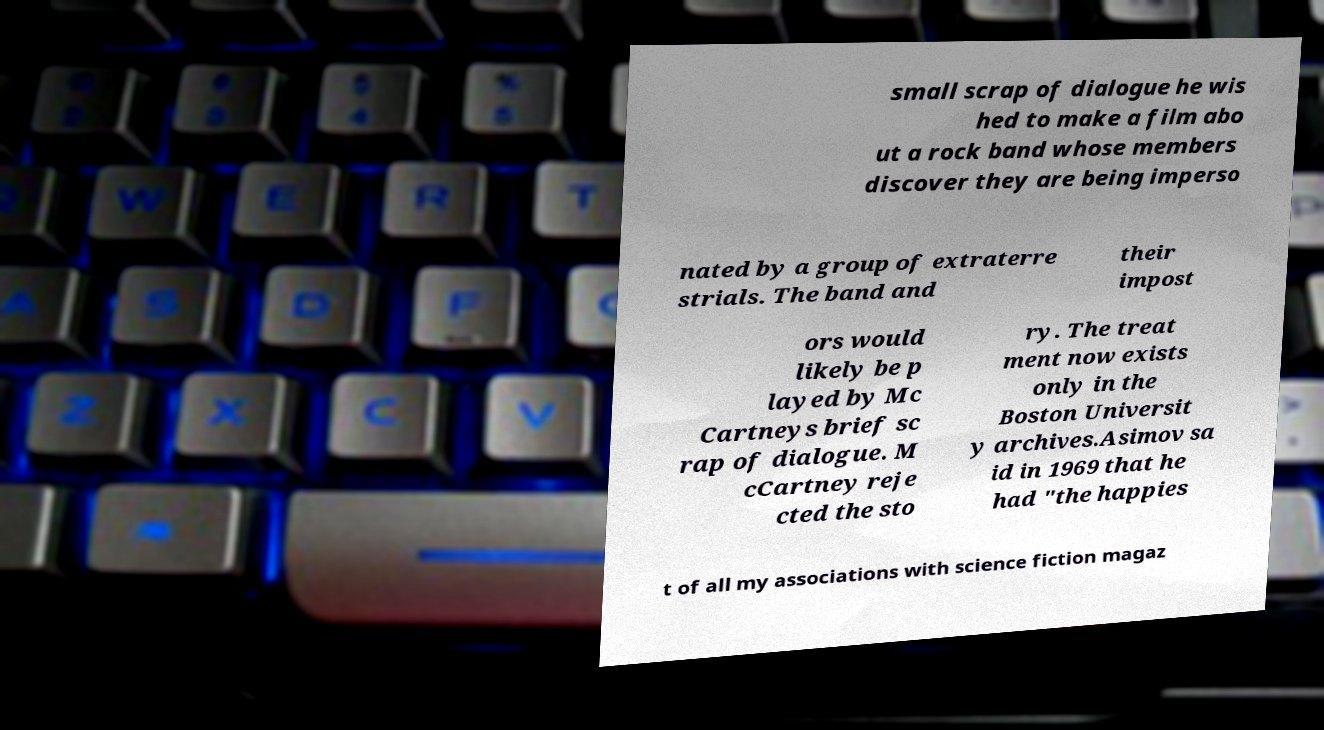Please read and relay the text visible in this image. What does it say? small scrap of dialogue he wis hed to make a film abo ut a rock band whose members discover they are being imperso nated by a group of extraterre strials. The band and their impost ors would likely be p layed by Mc Cartneys brief sc rap of dialogue. M cCartney reje cted the sto ry. The treat ment now exists only in the Boston Universit y archives.Asimov sa id in 1969 that he had "the happies t of all my associations with science fiction magaz 